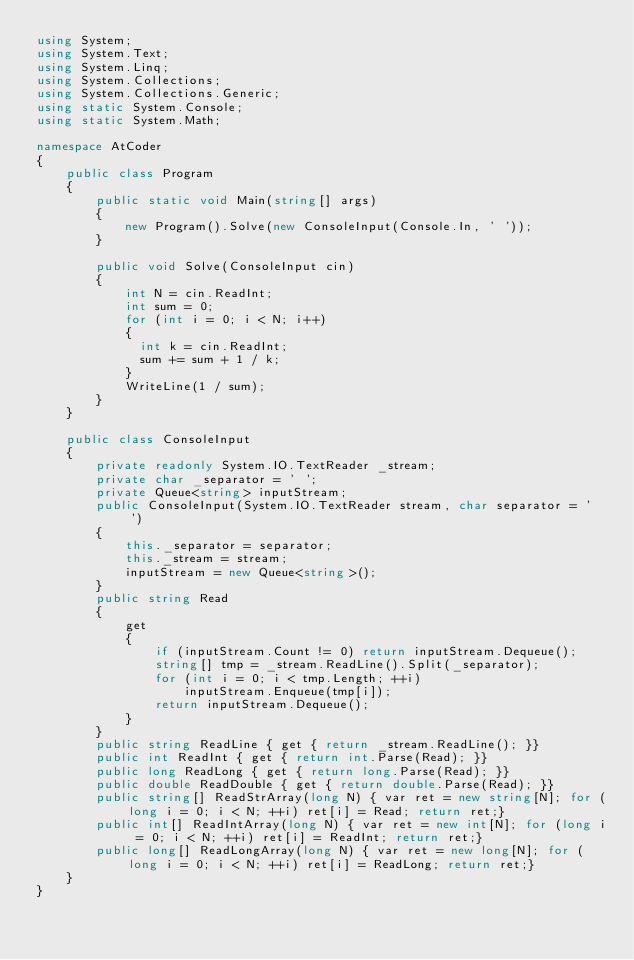Convert code to text. <code><loc_0><loc_0><loc_500><loc_500><_C#_>using System;
using System.Text;
using System.Linq;
using System.Collections;
using System.Collections.Generic;
using static System.Console;
using static System.Math;

namespace AtCoder
{
    public class Program
    {
        public static void Main(string[] args)
        {
            new Program().Solve(new ConsoleInput(Console.In, ' '));
        }

        public void Solve(ConsoleInput cin)
        {
         	int N = cin.ReadInt;
          	int sum = 0;
         	for (int i = 0; i < N; i++)
            {
              int k = cin.ReadInt;
          	  sum += sum + 1 / k;
            }
            WriteLine(1 / sum);
        }
    }

    public class ConsoleInput
    {
        private readonly System.IO.TextReader _stream;
        private char _separator = ' ';
        private Queue<string> inputStream;
        public ConsoleInput(System.IO.TextReader stream, char separator = ' ')
        {
            this._separator = separator;
            this._stream = stream;
            inputStream = new Queue<string>();
        }
        public string Read
        {
            get
            {
                if (inputStream.Count != 0) return inputStream.Dequeue();
                string[] tmp = _stream.ReadLine().Split(_separator);
                for (int i = 0; i < tmp.Length; ++i)
                    inputStream.Enqueue(tmp[i]);
                return inputStream.Dequeue();
            }
        }
        public string ReadLine { get { return _stream.ReadLine(); }}
        public int ReadInt { get { return int.Parse(Read); }}
        public long ReadLong { get { return long.Parse(Read); }}
        public double ReadDouble { get { return double.Parse(Read); }}
        public string[] ReadStrArray(long N) { var ret = new string[N]; for (long i = 0; i < N; ++i) ret[i] = Read; return ret;}
        public int[] ReadIntArray(long N) { var ret = new int[N]; for (long i = 0; i < N; ++i) ret[i] = ReadInt; return ret;}
        public long[] ReadLongArray(long N) { var ret = new long[N]; for (long i = 0; i < N; ++i) ret[i] = ReadLong; return ret;}
    }
}
</code> 